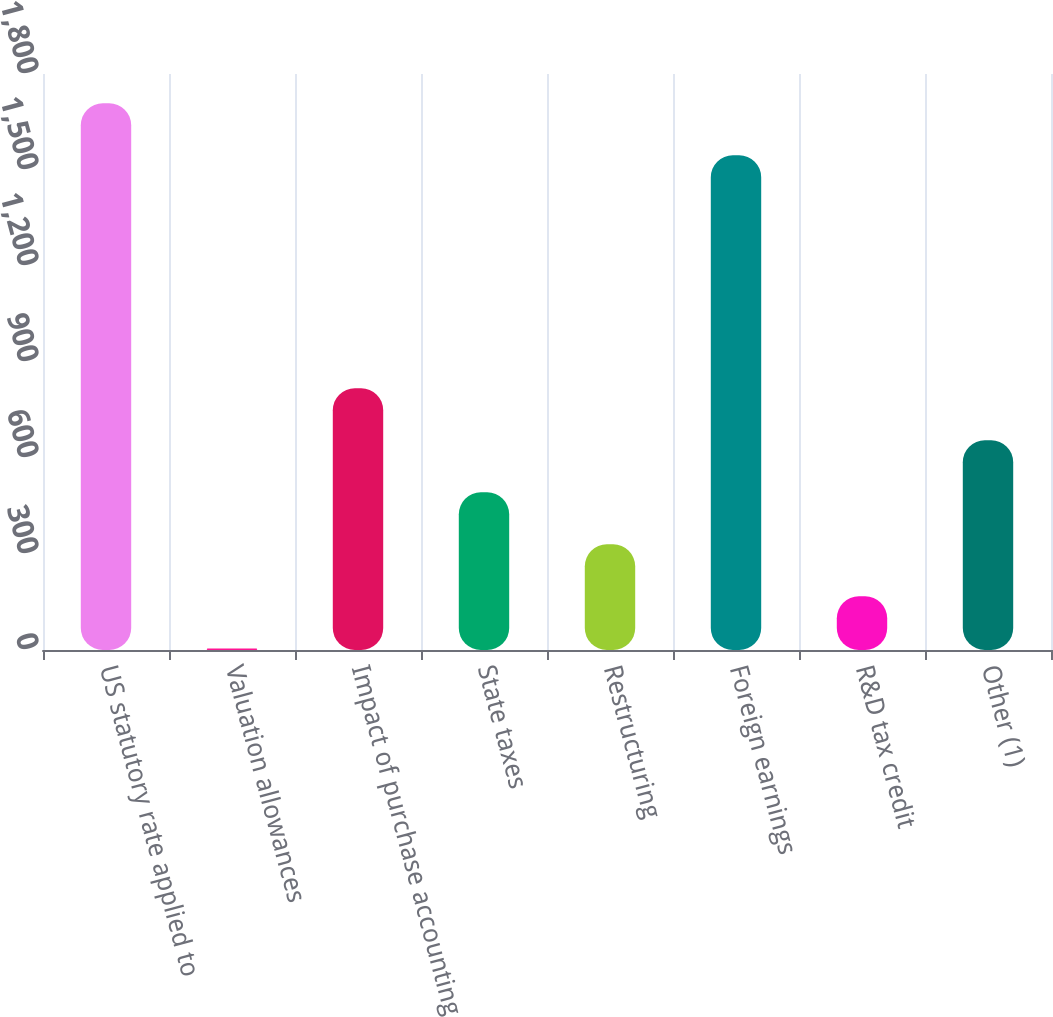Convert chart. <chart><loc_0><loc_0><loc_500><loc_500><bar_chart><fcel>US statutory rate applied to<fcel>Valuation allowances<fcel>Impact of purchase accounting<fcel>State taxes<fcel>Restructuring<fcel>Foreign earnings<fcel>R&D tax credit<fcel>Other (1)<nl><fcel>1708.6<fcel>5<fcel>818<fcel>492.8<fcel>330.2<fcel>1546<fcel>167.6<fcel>655.4<nl></chart> 